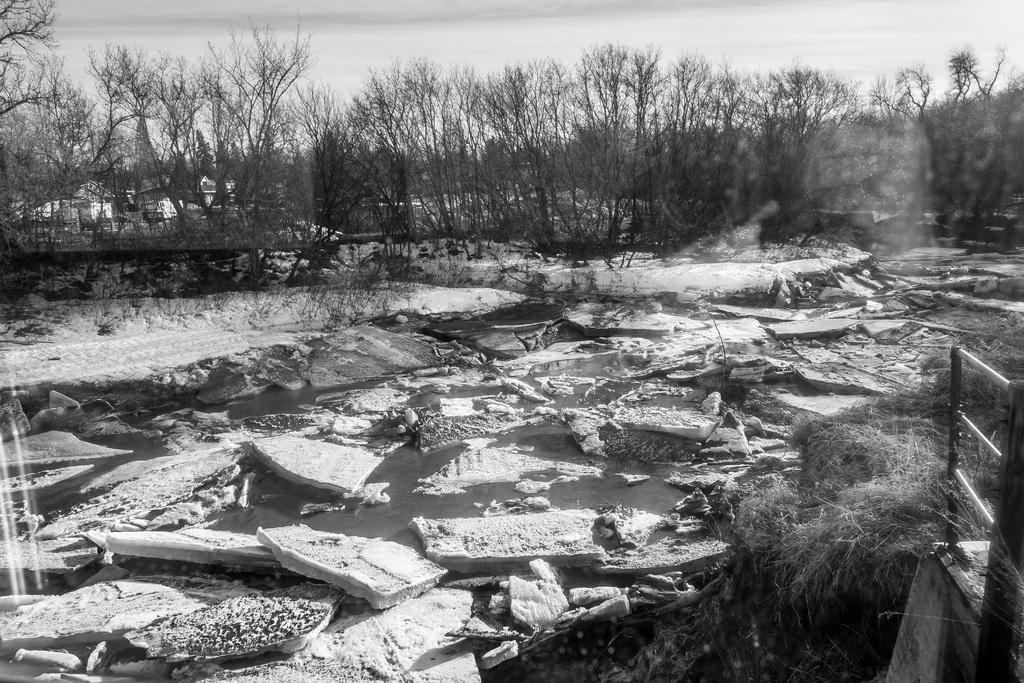What objects are floating on the water in the water in the image? There are broken wooden blocks floating on the water in the image. What type of vegetation can be seen in the image? There is grass visible in the image. What is located on the right side of the image? There is a metal fence on the right side of the image. What can be seen in the background of the image? There are trees in the background of the image. What type of fight is taking place in the image? There is no fight present in the image; it features broken wooden blocks floating on water, grass, a metal fence, and trees in the background. How many beams can be seen supporting the trees in the image? There is no mention of beams in the image; it only features broken wooden blocks, grass, a metal fence, and trees in the background. 